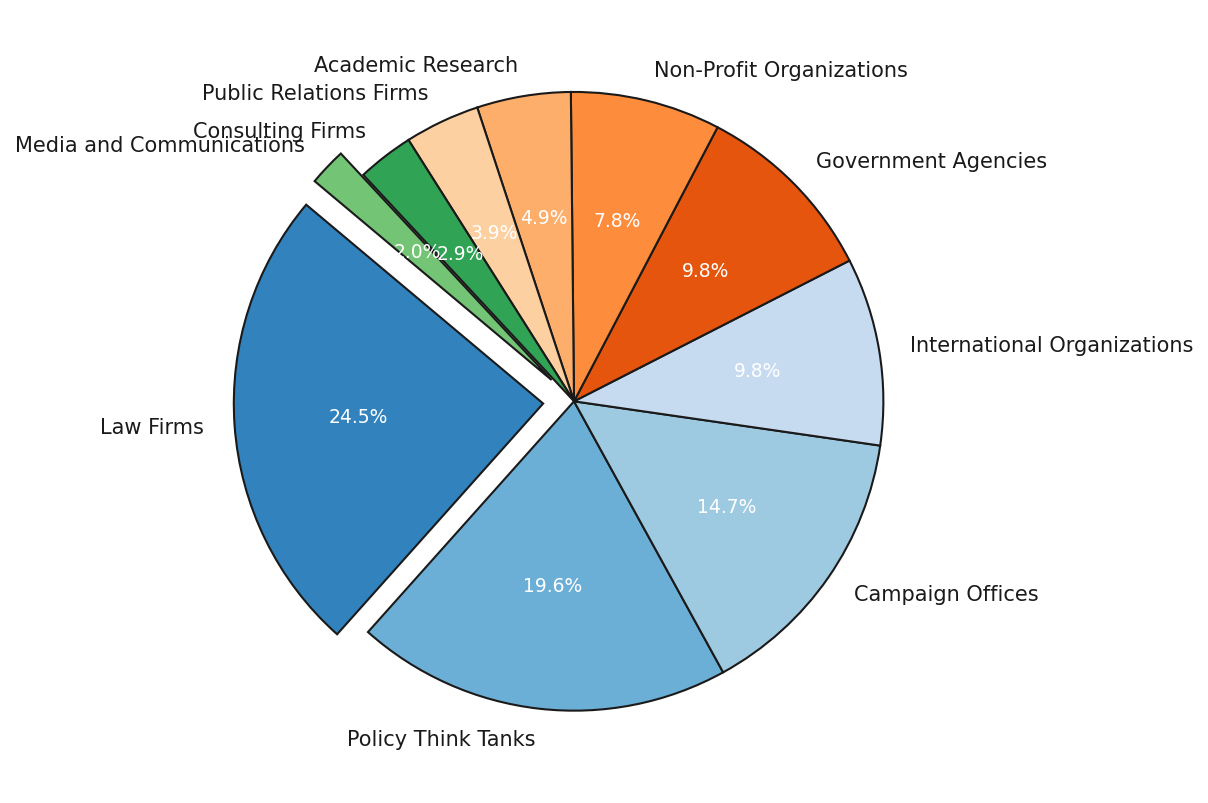Which internship field has the largest percentage of political science students? By observing the pie chart, the segment corresponding to Law Firms is the largest, indicating it has the highest percentage among all fields.
Answer: Law Firms Which internship fields together account for more than 50% of political science students? Adding the percentages of Law Firms (25%), Policy Think Tanks (20%), and Campaign Offices (15%), we collectively get: 25% + 20% + 15% = 60%, which is more than 50%
Answer: Law Firms, Policy Think Tanks, Campaign Offices Are there more students interning at Government Agencies or at Non-Profit Organizations? Comparing the sizes of the segments for Government Agencies (10%) and Non-Profit Organizations (8%) shows Government Agencies have a larger percentage.
Answer: Government Agencies What is the combined percentage for students interning in Public Relations Firms and Consulting Firms? Adding the percentages for Public Relations Firms (4%) and Consulting Firms (3%) gets: 4% + 3% = 7%
Answer: 7% Which three internship fields have the lowest percentages? From the pie chart, the smallest three segments correspond to Media and Communications (2%), Consulting Firms (3%), and Public Relations Firms (4%)
Answer: Media and Communications, Consulting Firms, Public Relations Firms What is the percentage difference between students interning at Campaign Offices and International Organizations? Subtracting the percentage of International Organizations (10%) from Campaign Offices (15%) gives the difference: 15% - 10% = 5%
Answer: 5% Which internship field accounts for exactly 10% of political science students? Observing the pie chart, the segments for International Organizations and Government Agencies both are marked at 10%.
Answer: International Organizations, Government Agencies How do the internship percentages compare between Law Firms and Policy Think Tanks? Law Firms have a percentage of 25% while Policy Think Tanks have 20%. Thus, Law Firms have a higher percentage compared to Policy Think Tanks.
Answer: Law Firms have a higher percentage How much more popular are Law Firms compared to Academic Research internships? Subtracting the percentage for Academic Research (5%) from that of Law Firms (25%) gives: 25% - 5% = 20%
Answer: 20% What is the relative size of the segment for Non-Profit Organizations as compared to Consulting Firms? The percentage for Non-Profit Organizations (8%) is higher than that for Consulting Firms (3%).
Answer: Non-Profit Organizations have a higher percentage 